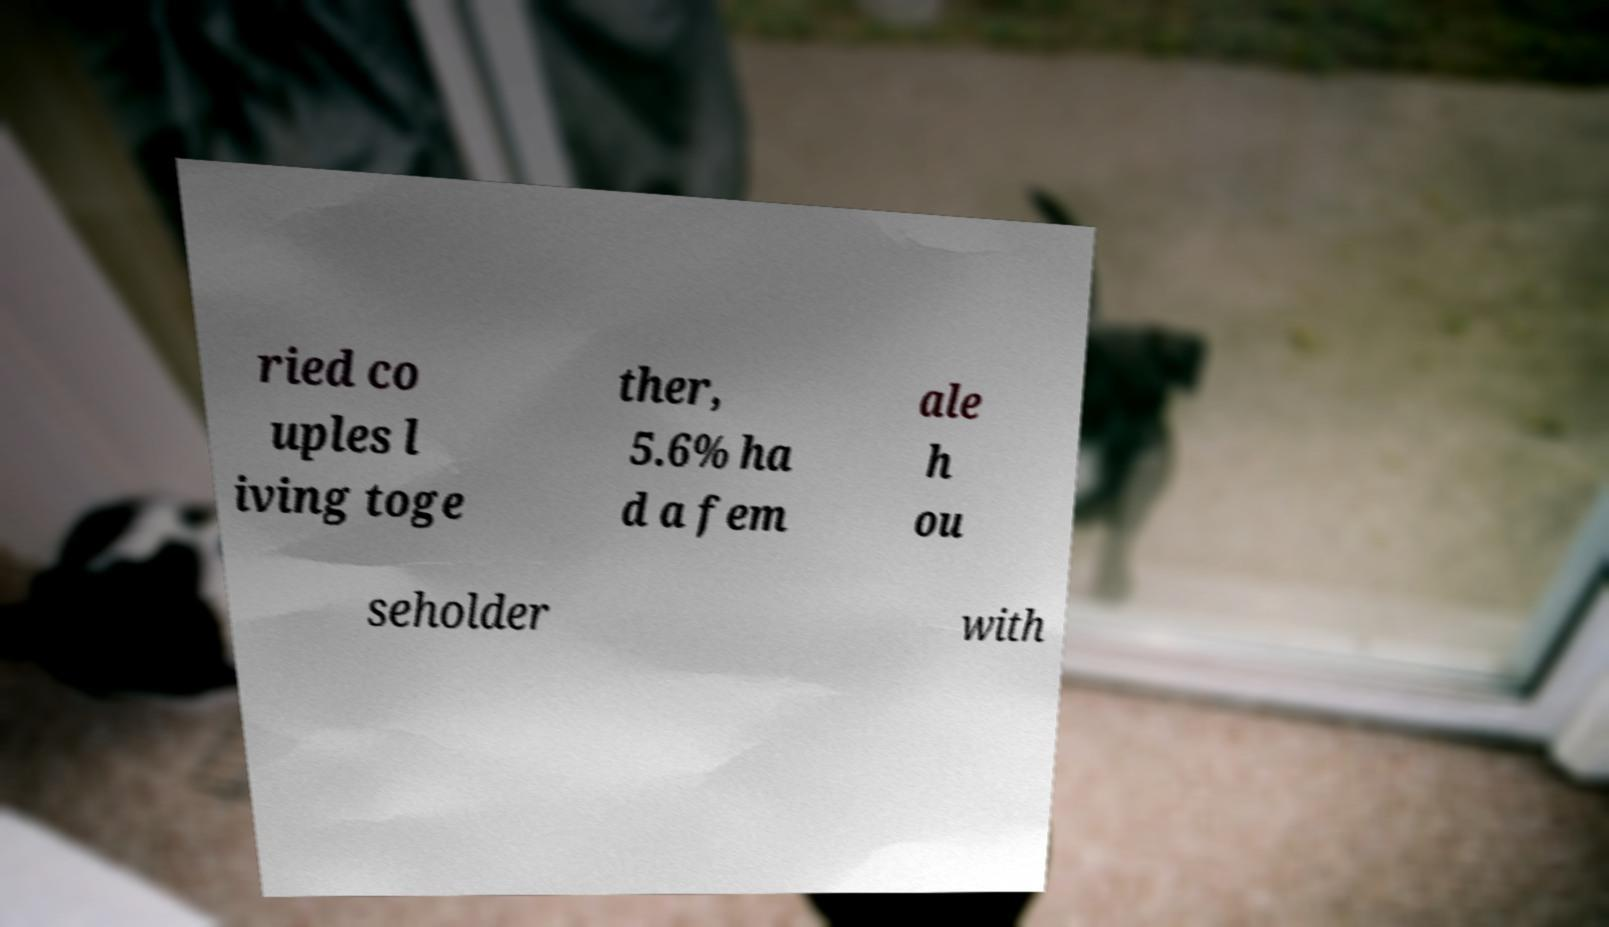For documentation purposes, I need the text within this image transcribed. Could you provide that? ried co uples l iving toge ther, 5.6% ha d a fem ale h ou seholder with 